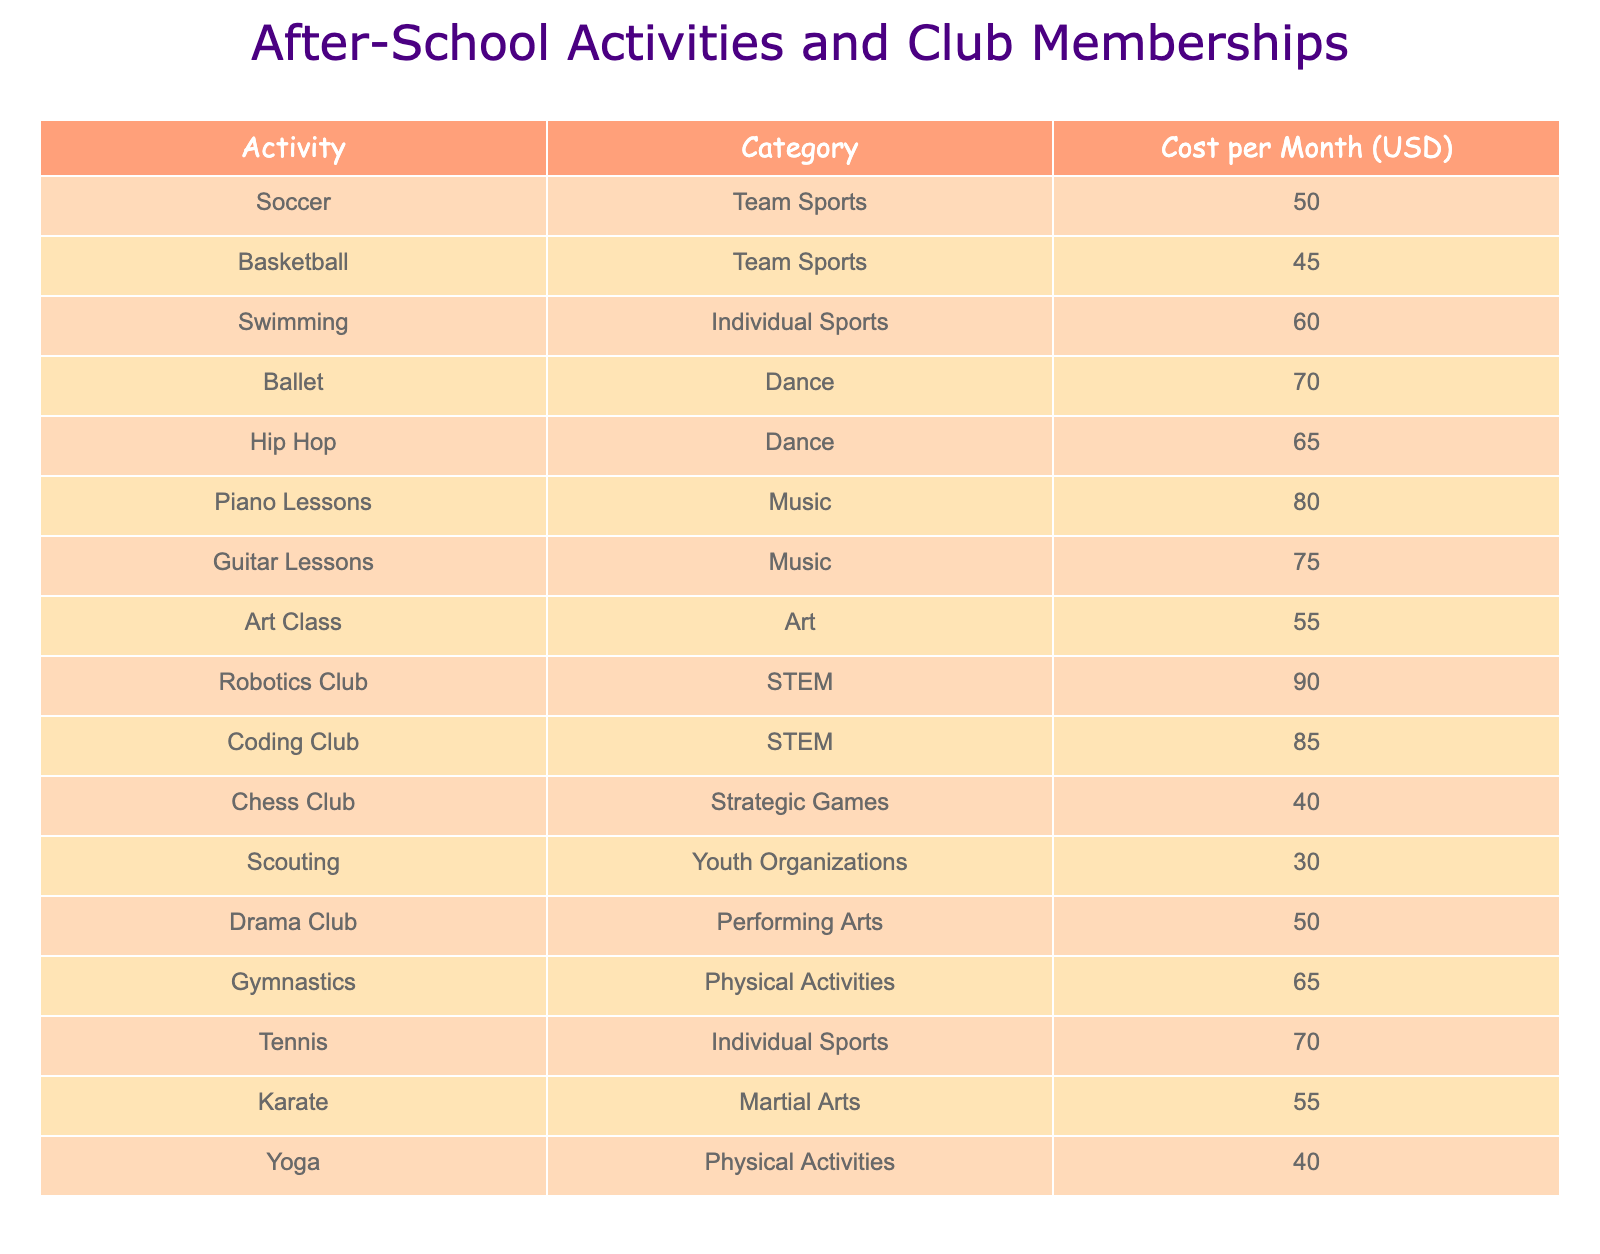What is the cost of joining the Robotics Club? The table lists activities along with their costs. To find the cost of the Robotics Club, we refer to the corresponding row in the table, which states that the cost is 90 USD per month.
Answer: 90 USD Which activity is the most expensive among the dance categories? Looking at the Dance category in the table, we see two activities: Ballet and Hip Hop. Their costs are 70 USD and 65 USD respectively. Ballet has the higher cost at 70 USD.
Answer: Ballet is the most expensive What is the average cost of all team sports listed? The team sports listed are Soccer and Basketball, costing 50 USD and 45 USD respectively. To find the average, we sum these costs: 50 + 45 = 95 and then divide by the number of activities (2): 95 / 2 = 47.5 USD.
Answer: 47.5 USD Is the Chess Club more expensive than the Scouting group? The Chess Club costs 40 USD per month while Scouting costs 30 USD. Since 40 is greater than 30, the statement is true.
Answer: Yes If a child participates in both Piano Lessons and Karate, what would be the total monthly cost? The cost of Piano Lessons is 80 USD and the cost of Karate is 55 USD. Adding these together gives us: 80 + 55 = 135 USD. Thus, the total monthly cost for both activities is 135 USD.
Answer: 135 USD Which category has the least expensive activity mentioned in the table? To find the least expensive activity, we examine all activities in the table. The cheapest option is Scouting, which costs 30 USD. The category it belongs to is Youth Organizations.
Answer: Youth Organizations How much more does it cost to join the Coding Club than the Chess Club? The Coding Club costs 85 USD and the Chess Club costs 40 USD. The difference is calculated by subtracting the Chess Club's cost from the Coding Club's cost: 85 - 40 = 45 USD.
Answer: 45 USD Are there more Individual Sports or Dance activities listed, and which ones are they? There are two Individual Sports (Swimming and Tennis) and two Dance activities (Ballet and Hip Hop), making them equal in number.
Answer: They are equal in number 